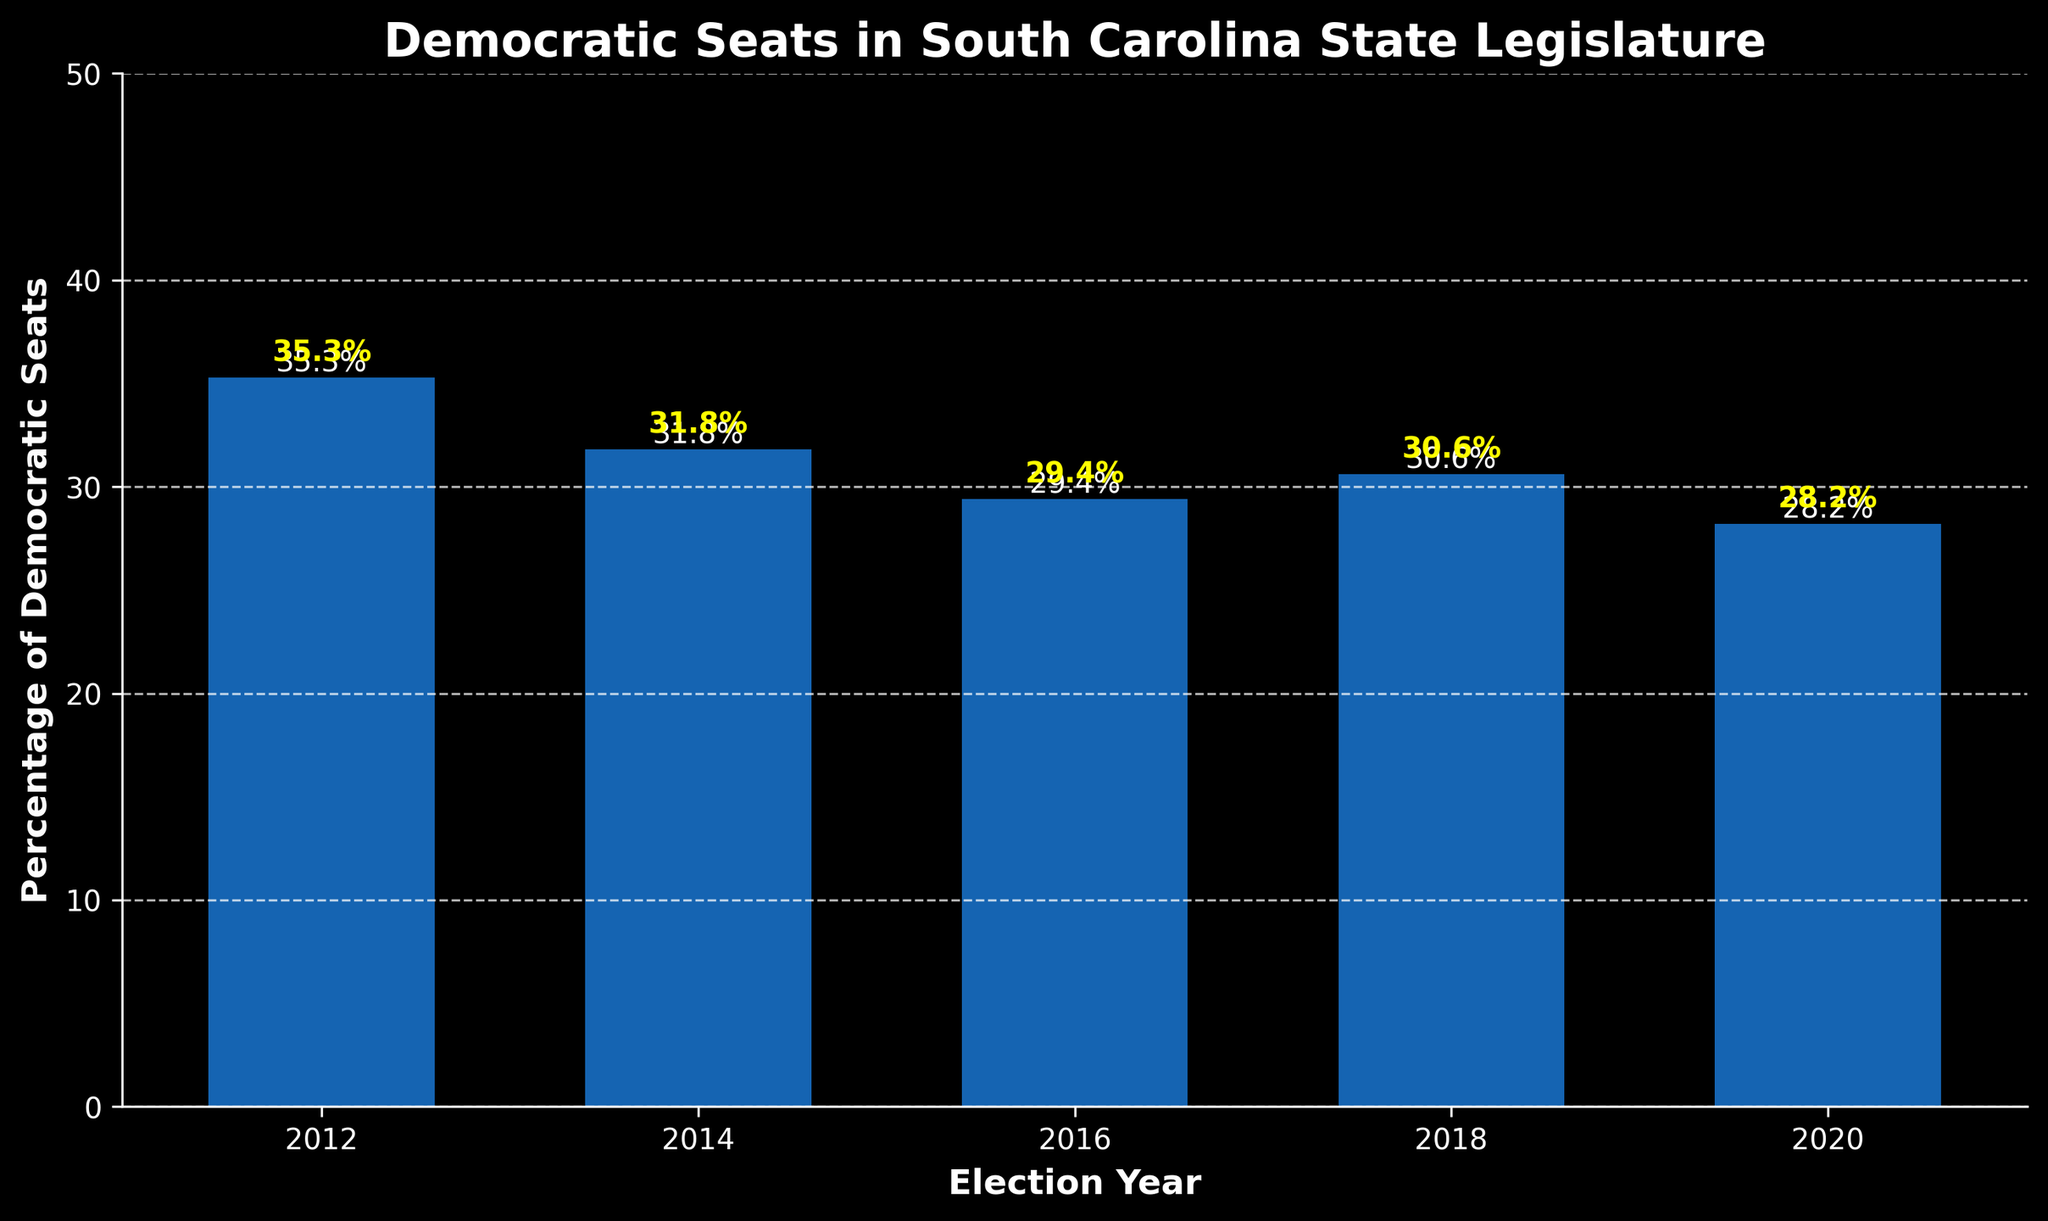What is the percentage of Democratic seats held in 2016? Look for the bar labeled '2016' and refer to its height. The vertical text next to the bar confirms the number.
Answer: 29.4% Which election year had the highest percentage of Democratic seats? Identify the tallest bar, indicating the highest value of Democratic seats, and read the corresponding year from the x-axis.
Answer: 2012 What is the difference in the percentage of Democratic seats between 2012 and 2020? Note the percentages for 2012 (35.3%) and 2020 (28.2%), and then subtract the latter from the former to find the difference.
Answer: 7.1% How did the percentage of Democratic seats change from 2014 to 2016? Observe the heights of the bars for 2014 and 2016 and note whether the bar in 2016 is taller or shorter.
Answer: Decreased What is the average percentage of Democratic seats over the 5 election cycles? Sum the percentages (35.3, 31.8, 29.4, 30.6, 28.2), then divide by 5 to get the average.
Answer: 31.1% In which year was the percentage of Democratic seats exactly between the values in 2014 and 2020? Compare the values to find the midpoint between 31.8% (2014) and 28.2% (2020), which is 30.0%. Identify any year close to this value—in this case, it is 2018 with 30.6%.
Answer: 2018 What trend do you observe in the percentage of Democratic seats from 2012 to 2020? Look at the sequence of bar heights from left (2012) to right (2020) and note whether they generally increase, decrease, or fluctuate.
Answer: Decreasing Which two consecutive election years had the smallest change in the percentage of Democratic seats? Compare the pairwise differences between consecutive years and identify the smallest gap. (31.8 - 29.4 = 2.4; 29.4 - 30.6 = 1.2; 30.6 - 28.2 = 2.4; smallest is 1.2 between 2016 and 2018)
Answer: 2016 and 2018 What is the overall decrease in percentage from the highest to the lowest value over the given period? Identify the highest (35.3% in 2012) and lowest (28.2% in 2020) values, then subtract the lowest from the highest to find the total decrease.
Answer: 7.1% 